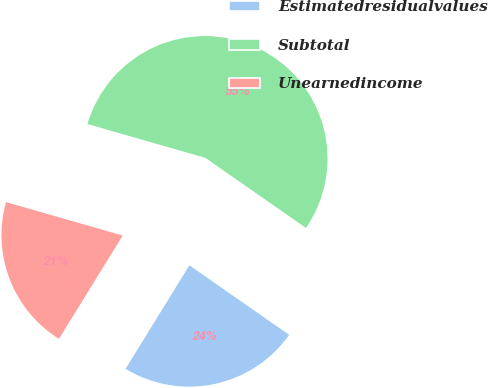<chart> <loc_0><loc_0><loc_500><loc_500><pie_chart><fcel>Estimatedresidualvalues<fcel>Subtotal<fcel>Unearnedincome<nl><fcel>24.11%<fcel>55.25%<fcel>20.65%<nl></chart> 